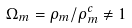<formula> <loc_0><loc_0><loc_500><loc_500>\Omega _ { m } = \rho _ { m } / \rho _ { m } ^ { c } \neq 1</formula> 